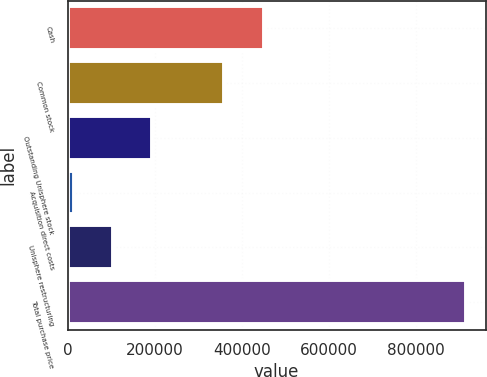<chart> <loc_0><loc_0><loc_500><loc_500><bar_chart><fcel>Cash<fcel>Common stock<fcel>Outstanding Unisphere stock<fcel>Acquisition direct costs<fcel>Unisphere restructuring<fcel>Total purchase price<nl><fcel>449981<fcel>359888<fcel>193792<fcel>13607<fcel>103700<fcel>914533<nl></chart> 